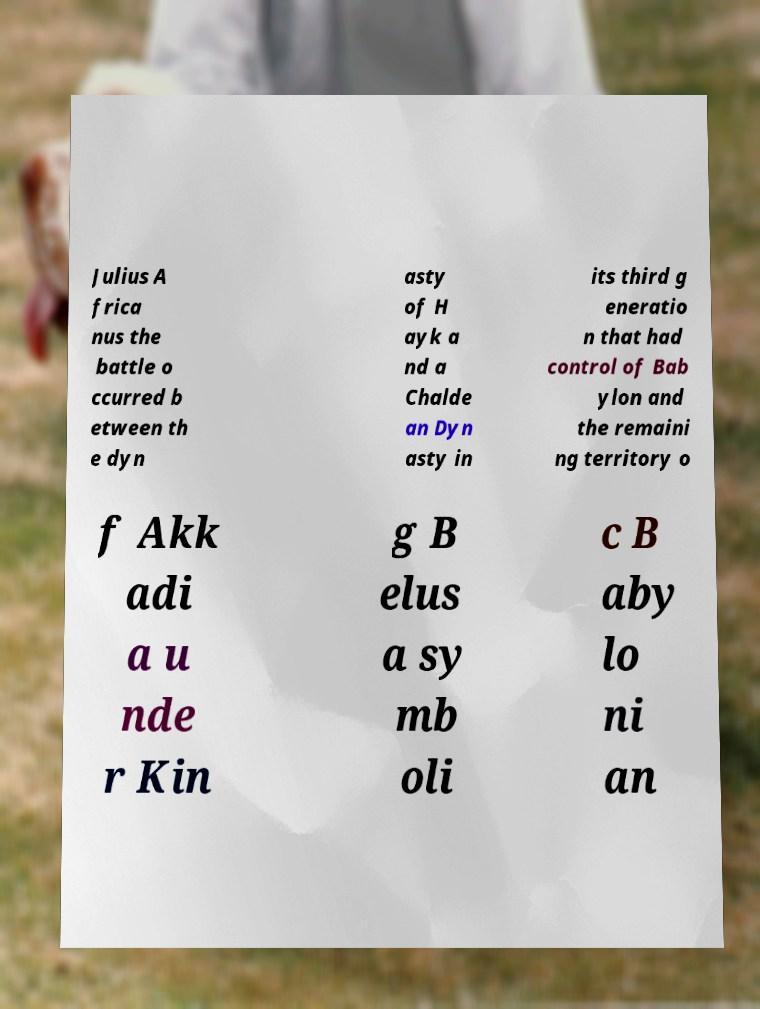Please read and relay the text visible in this image. What does it say? Julius A frica nus the battle o ccurred b etween th e dyn asty of H ayk a nd a Chalde an Dyn asty in its third g eneratio n that had control of Bab ylon and the remaini ng territory o f Akk adi a u nde r Kin g B elus a sy mb oli c B aby lo ni an 